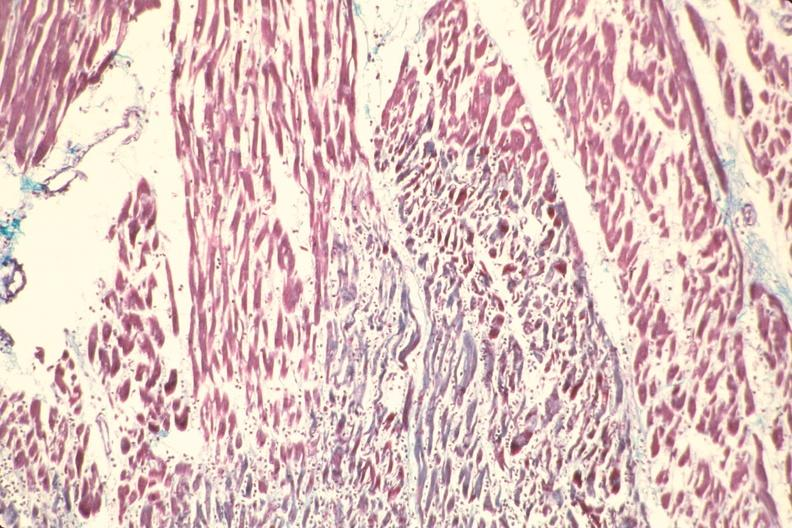does chest and abdomen slide show heart, acute myocardial infarction?
Answer the question using a single word or phrase. No 